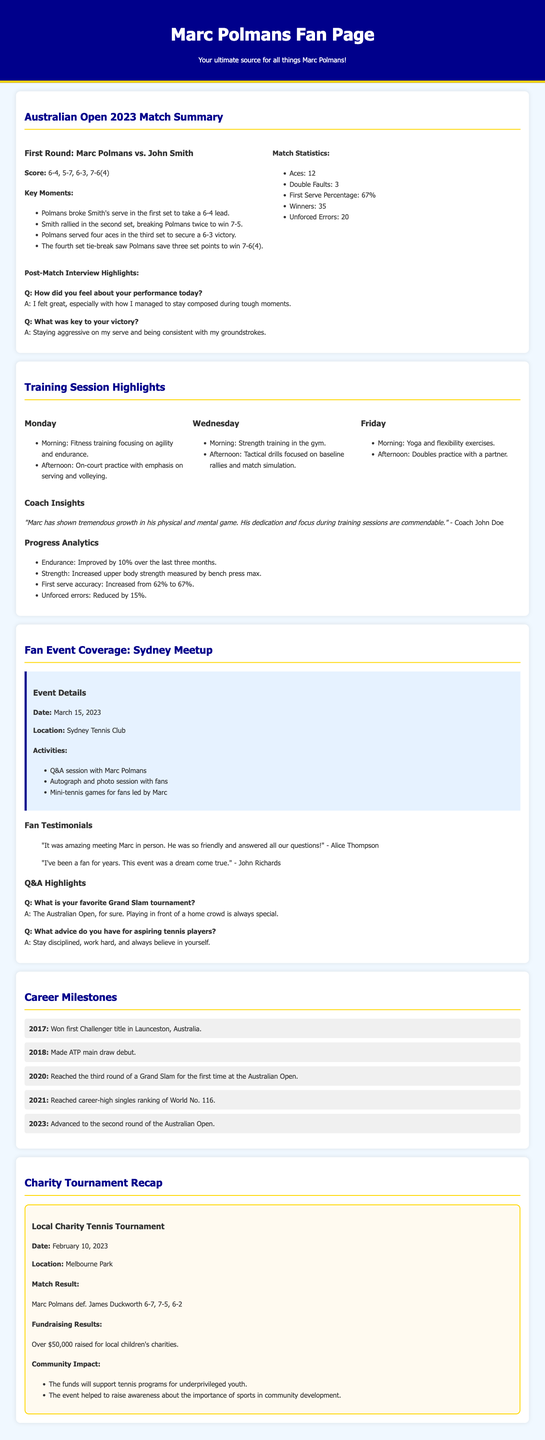What was the score in Marc Polmans' first-round match? The score is detailed under the match summary section, which indicates it was 6-4, 5-7, 6-3, 7-6(4).
Answer: 6-4, 5-7, 6-3, 7-6(4) How many aces did Marc Polmans serve during the match? The number of aces is listed in the match statistics, which states he served 12 aces.
Answer: 12 What is the date of the local charity tennis tournament? The date can be found in the charity tournament recap, which specifies February 10, 2023.
Answer: February 10, 2023 What fundraising amount was raised for local children's charities? The fundraising results are mentioned in the charity tournament section, highlighting over $50,000 raised.
Answer: Over $50,000 What is Marc Polmans' favorite Grand Slam tournament according to the fan event? This information comes from the Q&A highlights, where he mentions the Australian Open is his favorite.
Answer: The Australian Open What progress improvement percentage is noted for Marc Polmans' endurance? This detail is available in the progress analytics where it's stated he improved by 10%.
Answer: 10% Which year did Marc Polmans reach his career-high singles ranking? The career milestones section states he reached this ranking in 2021.
Answer: 2021 What was a key moment in the fourth set of the match? A crucial moment is specified in the key moments list, noting he saved three set points to win 7-6(4).
Answer: Saved three set points Who provided insights about Marc Polmans' training? The insights are attributed to his coach, John Doe, as mentioned in the training session highlights.
Answer: Coach John Doe 